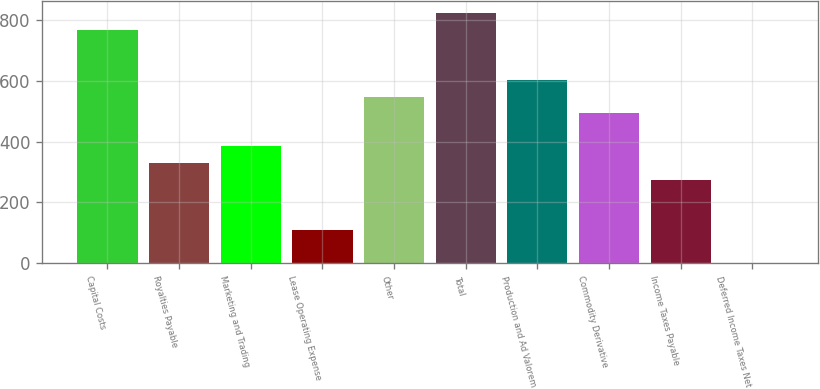Convert chart. <chart><loc_0><loc_0><loc_500><loc_500><bar_chart><fcel>Capital Costs<fcel>Royalties Payable<fcel>Marketing and Trading<fcel>Lease Operating Expense<fcel>Other<fcel>Total<fcel>Production and Ad Valorem<fcel>Commodity Derivative<fcel>Income Taxes Payable<fcel>Deferred Income Taxes Net<nl><fcel>766.8<fcel>329.2<fcel>383.9<fcel>110.4<fcel>548<fcel>821.5<fcel>602.7<fcel>493.3<fcel>274.5<fcel>1<nl></chart> 